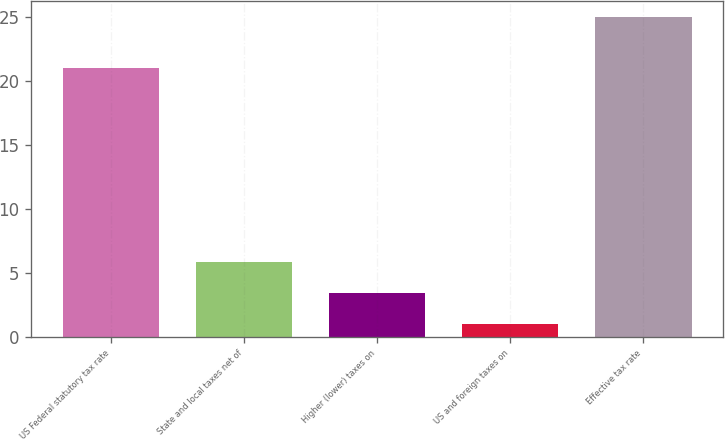Convert chart. <chart><loc_0><loc_0><loc_500><loc_500><bar_chart><fcel>US Federal statutory tax rate<fcel>State and local taxes net of<fcel>Higher (lower) taxes on<fcel>US and foreign taxes on<fcel>Effective tax rate<nl><fcel>21<fcel>5.8<fcel>3.4<fcel>1<fcel>25<nl></chart> 